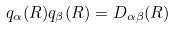<formula> <loc_0><loc_0><loc_500><loc_500>q _ { \alpha } ( { R } ) q _ { \beta } ( { R } ) = D _ { \alpha \beta } ( { R } )</formula> 